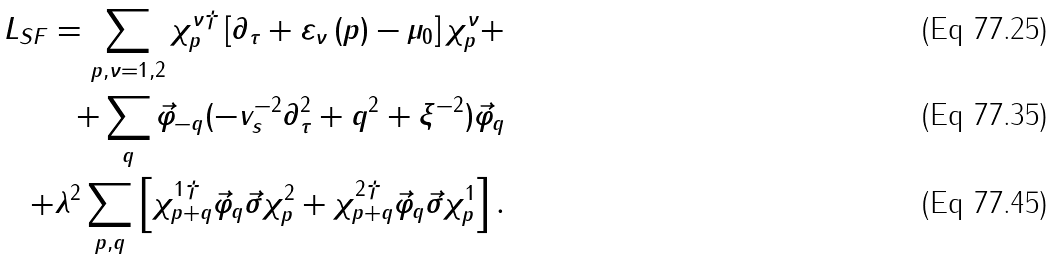<formula> <loc_0><loc_0><loc_500><loc_500>L _ { S F } = \sum _ { p , \nu = 1 , 2 } \chi _ { p } ^ { \nu \dagger } \left [ \partial _ { \tau } + \varepsilon _ { \nu } \left ( p \right ) - \mu _ { 0 } \right ] \chi _ { p } ^ { \nu } + \\ + \sum _ { q } \vec { \varphi } _ { - q } ( - v _ { s } ^ { - 2 } \partial _ { \tau } ^ { 2 } + q ^ { 2 } + \xi ^ { - 2 } ) \vec { \varphi } _ { q } \\ + \lambda ^ { 2 } \sum _ { p , q } \left [ \chi _ { p + q } ^ { 1 \dagger } \vec { \varphi } _ { q } \vec { \sigma } \chi _ { p } ^ { 2 } + \chi _ { p + q } ^ { 2 \dagger } \vec { \varphi } _ { q } \vec { \sigma } \chi _ { p } ^ { 1 } \right ] .</formula> 